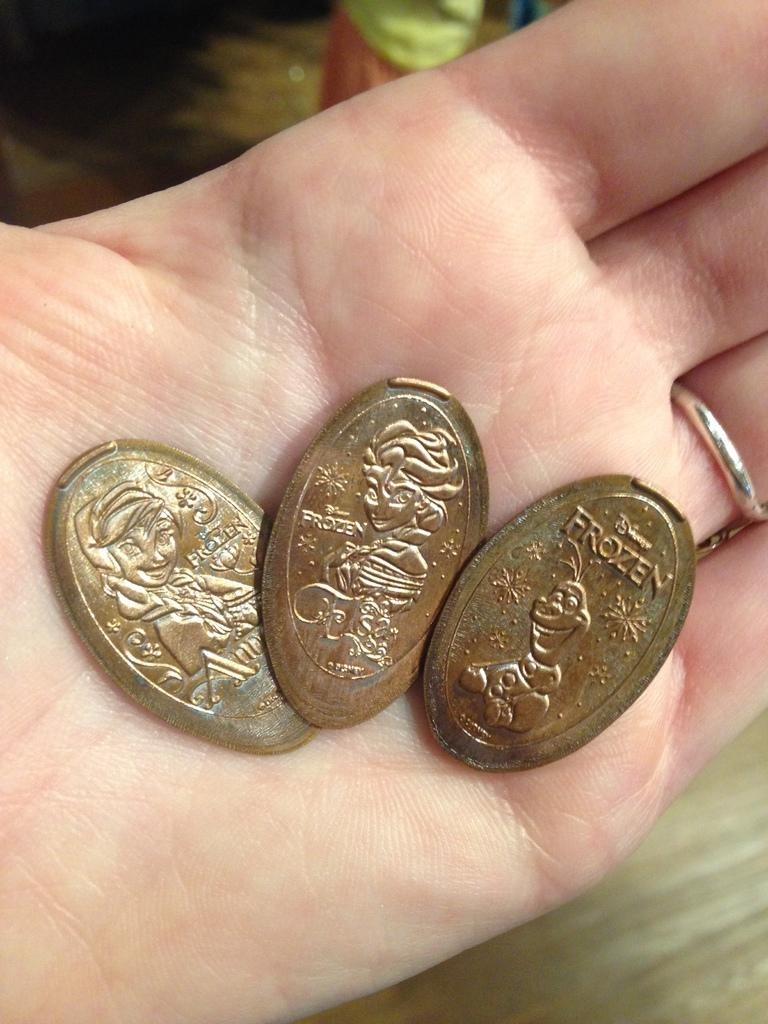<image>
Write a terse but informative summary of the picture. several Frozen bronze coins are in a person's hand 